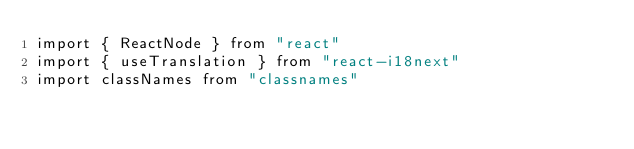Convert code to text. <code><loc_0><loc_0><loc_500><loc_500><_TypeScript_>import { ReactNode } from "react"
import { useTranslation } from "react-i18next"
import classNames from "classnames"</code> 